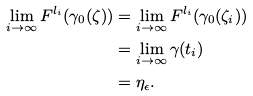<formula> <loc_0><loc_0><loc_500><loc_500>\lim _ { i \rightarrow \infty } F ^ { l _ { i } } ( \gamma _ { 0 } ( \zeta ) ) & = \lim _ { i \rightarrow \infty } F ^ { l _ { i } } ( \gamma _ { 0 } ( \zeta _ { i } ) ) \\ & = \lim _ { i \rightarrow \infty } \gamma ( t _ { i } ) \\ & = \eta _ { \epsilon } .</formula> 